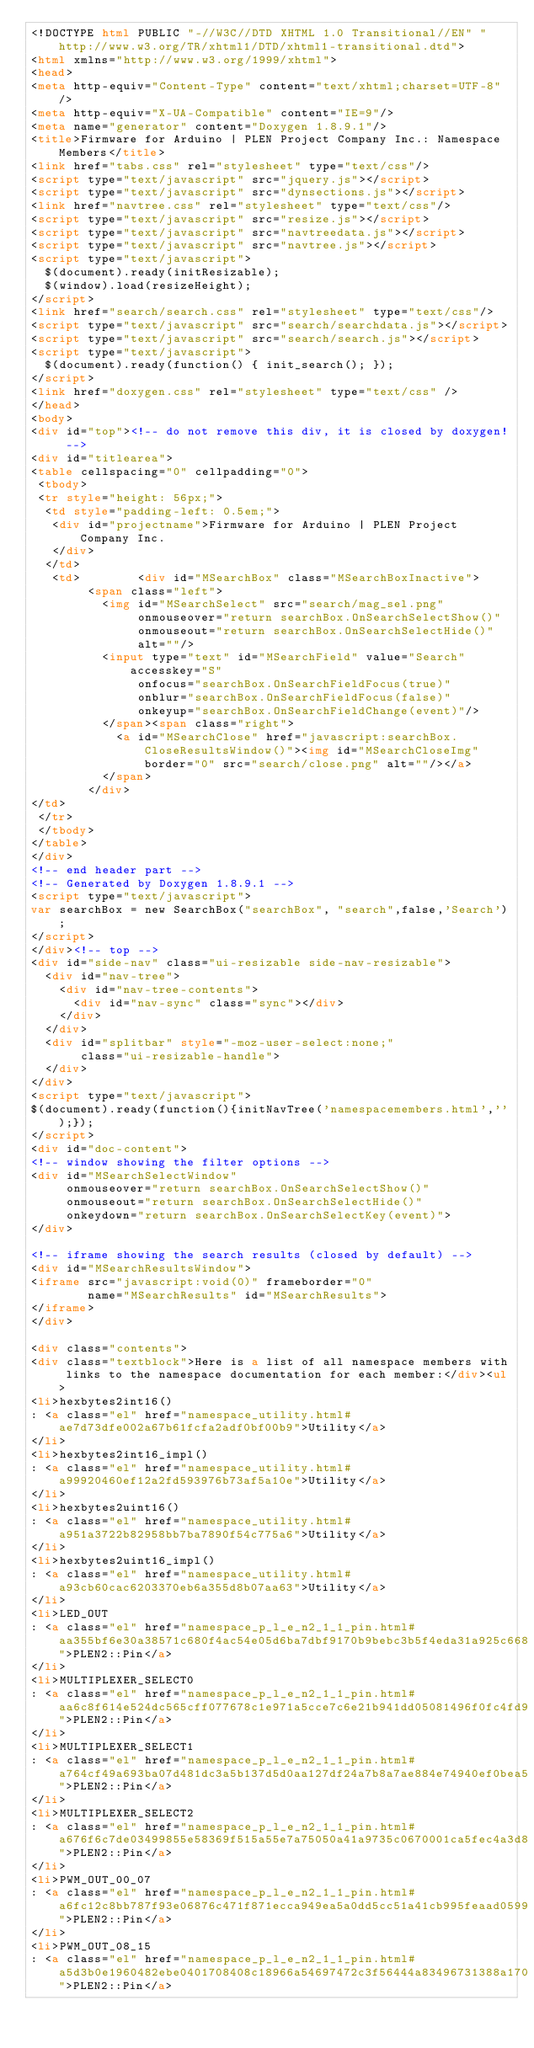Convert code to text. <code><loc_0><loc_0><loc_500><loc_500><_HTML_><!DOCTYPE html PUBLIC "-//W3C//DTD XHTML 1.0 Transitional//EN" "http://www.w3.org/TR/xhtml1/DTD/xhtml1-transitional.dtd">
<html xmlns="http://www.w3.org/1999/xhtml">
<head>
<meta http-equiv="Content-Type" content="text/xhtml;charset=UTF-8"/>
<meta http-equiv="X-UA-Compatible" content="IE=9"/>
<meta name="generator" content="Doxygen 1.8.9.1"/>
<title>Firmware for Arduino | PLEN Project Company Inc.: Namespace Members</title>
<link href="tabs.css" rel="stylesheet" type="text/css"/>
<script type="text/javascript" src="jquery.js"></script>
<script type="text/javascript" src="dynsections.js"></script>
<link href="navtree.css" rel="stylesheet" type="text/css"/>
<script type="text/javascript" src="resize.js"></script>
<script type="text/javascript" src="navtreedata.js"></script>
<script type="text/javascript" src="navtree.js"></script>
<script type="text/javascript">
  $(document).ready(initResizable);
  $(window).load(resizeHeight);
</script>
<link href="search/search.css" rel="stylesheet" type="text/css"/>
<script type="text/javascript" src="search/searchdata.js"></script>
<script type="text/javascript" src="search/search.js"></script>
<script type="text/javascript">
  $(document).ready(function() { init_search(); });
</script>
<link href="doxygen.css" rel="stylesheet" type="text/css" />
</head>
<body>
<div id="top"><!-- do not remove this div, it is closed by doxygen! -->
<div id="titlearea">
<table cellspacing="0" cellpadding="0">
 <tbody>
 <tr style="height: 56px;">
  <td style="padding-left: 0.5em;">
   <div id="projectname">Firmware for Arduino | PLEN Project Company Inc.
   </div>
  </td>
   <td>        <div id="MSearchBox" class="MSearchBoxInactive">
        <span class="left">
          <img id="MSearchSelect" src="search/mag_sel.png"
               onmouseover="return searchBox.OnSearchSelectShow()"
               onmouseout="return searchBox.OnSearchSelectHide()"
               alt=""/>
          <input type="text" id="MSearchField" value="Search" accesskey="S"
               onfocus="searchBox.OnSearchFieldFocus(true)" 
               onblur="searchBox.OnSearchFieldFocus(false)" 
               onkeyup="searchBox.OnSearchFieldChange(event)"/>
          </span><span class="right">
            <a id="MSearchClose" href="javascript:searchBox.CloseResultsWindow()"><img id="MSearchCloseImg" border="0" src="search/close.png" alt=""/></a>
          </span>
        </div>
</td>
 </tr>
 </tbody>
</table>
</div>
<!-- end header part -->
<!-- Generated by Doxygen 1.8.9.1 -->
<script type="text/javascript">
var searchBox = new SearchBox("searchBox", "search",false,'Search');
</script>
</div><!-- top -->
<div id="side-nav" class="ui-resizable side-nav-resizable">
  <div id="nav-tree">
    <div id="nav-tree-contents">
      <div id="nav-sync" class="sync"></div>
    </div>
  </div>
  <div id="splitbar" style="-moz-user-select:none;" 
       class="ui-resizable-handle">
  </div>
</div>
<script type="text/javascript">
$(document).ready(function(){initNavTree('namespacemembers.html','');});
</script>
<div id="doc-content">
<!-- window showing the filter options -->
<div id="MSearchSelectWindow"
     onmouseover="return searchBox.OnSearchSelectShow()"
     onmouseout="return searchBox.OnSearchSelectHide()"
     onkeydown="return searchBox.OnSearchSelectKey(event)">
</div>

<!-- iframe showing the search results (closed by default) -->
<div id="MSearchResultsWindow">
<iframe src="javascript:void(0)" frameborder="0" 
        name="MSearchResults" id="MSearchResults">
</iframe>
</div>

<div class="contents">
<div class="textblock">Here is a list of all namespace members with links to the namespace documentation for each member:</div><ul>
<li>hexbytes2int16()
: <a class="el" href="namespace_utility.html#ae7d73dfe002a67b61fcfa2adf0bf00b9">Utility</a>
</li>
<li>hexbytes2int16_impl()
: <a class="el" href="namespace_utility.html#a99920460ef12a2fd593976b73af5a10e">Utility</a>
</li>
<li>hexbytes2uint16()
: <a class="el" href="namespace_utility.html#a951a3722b82958bb7ba7890f54c775a6">Utility</a>
</li>
<li>hexbytes2uint16_impl()
: <a class="el" href="namespace_utility.html#a93cb60cac6203370eb6a355d8b07aa63">Utility</a>
</li>
<li>LED_OUT
: <a class="el" href="namespace_p_l_e_n2_1_1_pin.html#aa355bf6e30a38571c680f4ac54e05d6ba7dbf9170b9bebc3b5f4eda31a925c668">PLEN2::Pin</a>
</li>
<li>MULTIPLEXER_SELECT0
: <a class="el" href="namespace_p_l_e_n2_1_1_pin.html#aa6c8f614e524dc565cff077678c1e971a5cce7c6e21b941dd05081496f0fc4fd9">PLEN2::Pin</a>
</li>
<li>MULTIPLEXER_SELECT1
: <a class="el" href="namespace_p_l_e_n2_1_1_pin.html#a764cf49a693ba07d481dc3a5b137d5d0aa127df24a7b8a7ae884e74940ef0bea5">PLEN2::Pin</a>
</li>
<li>MULTIPLEXER_SELECT2
: <a class="el" href="namespace_p_l_e_n2_1_1_pin.html#a676f6c7de03499855e58369f515a55e7a75050a41a9735c0670001ca5fec4a3d8">PLEN2::Pin</a>
</li>
<li>PWM_OUT_00_07
: <a class="el" href="namespace_p_l_e_n2_1_1_pin.html#a6fc12c8bb787f93e06876c471f871ecca949ea5a0dd5cc51a41cb995feaad0599">PLEN2::Pin</a>
</li>
<li>PWM_OUT_08_15
: <a class="el" href="namespace_p_l_e_n2_1_1_pin.html#a5d3b0e1960482ebe0401708408c18966a54697472c3f56444a83496731388a170">PLEN2::Pin</a></code> 